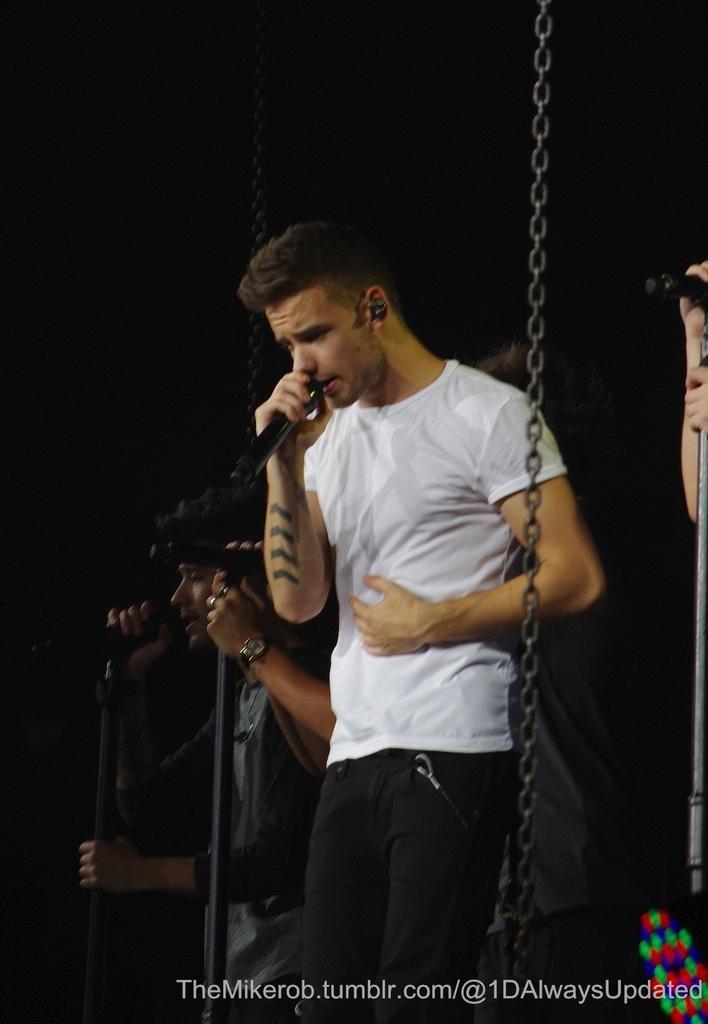In one or two sentences, can you explain what this image depicts? There is a man standing in the middle ,He is holding a microphone and singing a song , In the right side of the image there is a person standing and holding a microphone and there is a chain of black color and in the background there is a black color. 